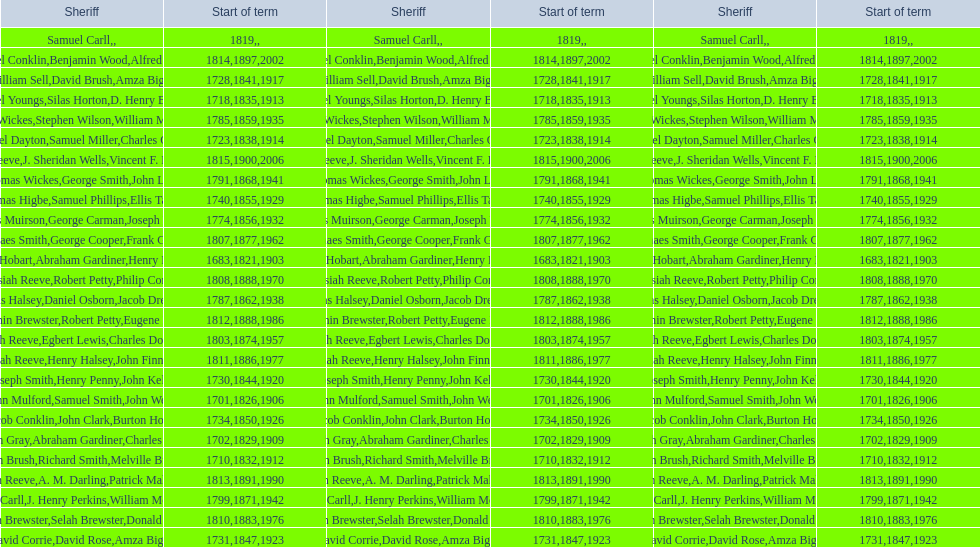Did robert petty serve before josiah reeve? No. 